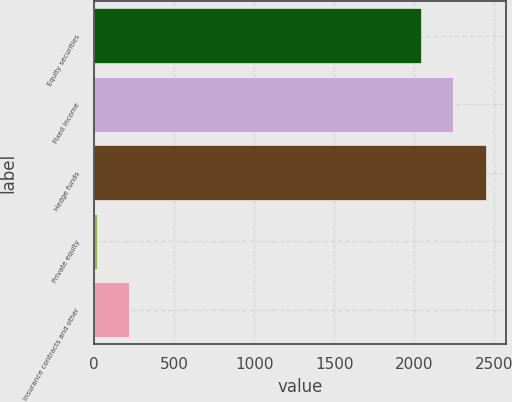<chart> <loc_0><loc_0><loc_500><loc_500><bar_chart><fcel>Equity securities<fcel>Fixed income<fcel>Hedge funds<fcel>Private equity<fcel>Insurance contracts and other<nl><fcel>2040<fcel>2244.5<fcel>2449<fcel>15<fcel>219.5<nl></chart> 